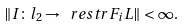<formula> <loc_0><loc_0><loc_500><loc_500>\| I \colon l _ { 2 } \to \ r e s t r { F _ { i } } { L } \| < \infty .</formula> 